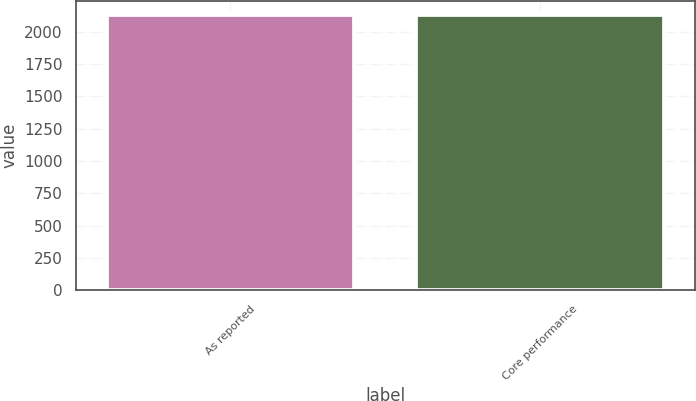Convert chart. <chart><loc_0><loc_0><loc_500><loc_500><bar_chart><fcel>As reported<fcel>Core performance<nl><fcel>2130<fcel>2130.1<nl></chart> 